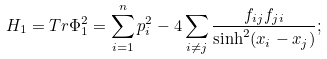Convert formula to latex. <formula><loc_0><loc_0><loc_500><loc_500>H _ { 1 } = T r \Phi _ { 1 } ^ { 2 } = \sum _ { i = 1 } ^ { n } p _ { i } ^ { 2 } - 4 \sum _ { i \neq j } \frac { f _ { i j } f _ { j i } } { \sinh ^ { 2 } ( x _ { i } - x _ { j } ) } ;</formula> 